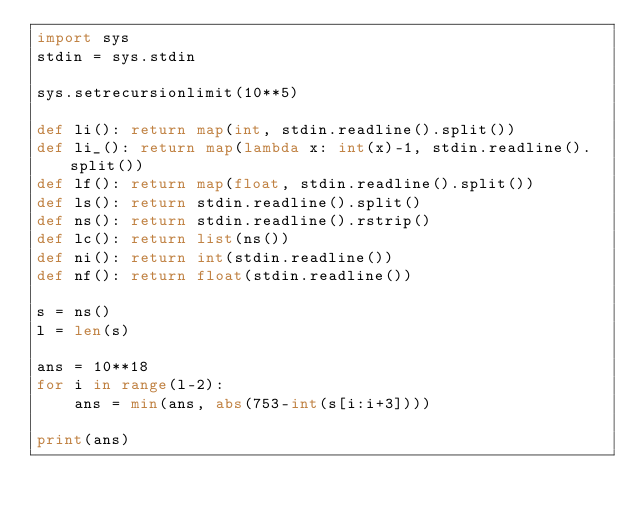<code> <loc_0><loc_0><loc_500><loc_500><_Python_>import sys
stdin = sys.stdin

sys.setrecursionlimit(10**5)

def li(): return map(int, stdin.readline().split())
def li_(): return map(lambda x: int(x)-1, stdin.readline().split())
def lf(): return map(float, stdin.readline().split())
def ls(): return stdin.readline().split()
def ns(): return stdin.readline().rstrip()
def lc(): return list(ns())
def ni(): return int(stdin.readline())
def nf(): return float(stdin.readline())

s = ns()
l = len(s)

ans = 10**18
for i in range(l-2):
    ans = min(ans, abs(753-int(s[i:i+3])))
    
print(ans)</code> 